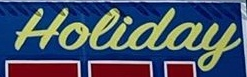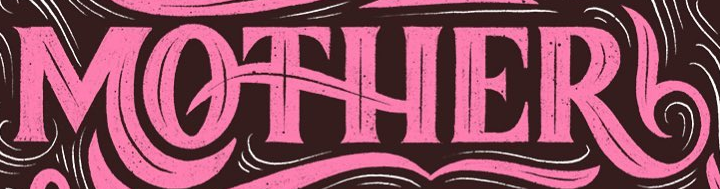What words are shown in these images in order, separated by a semicolon? Holiday; MOTHER 